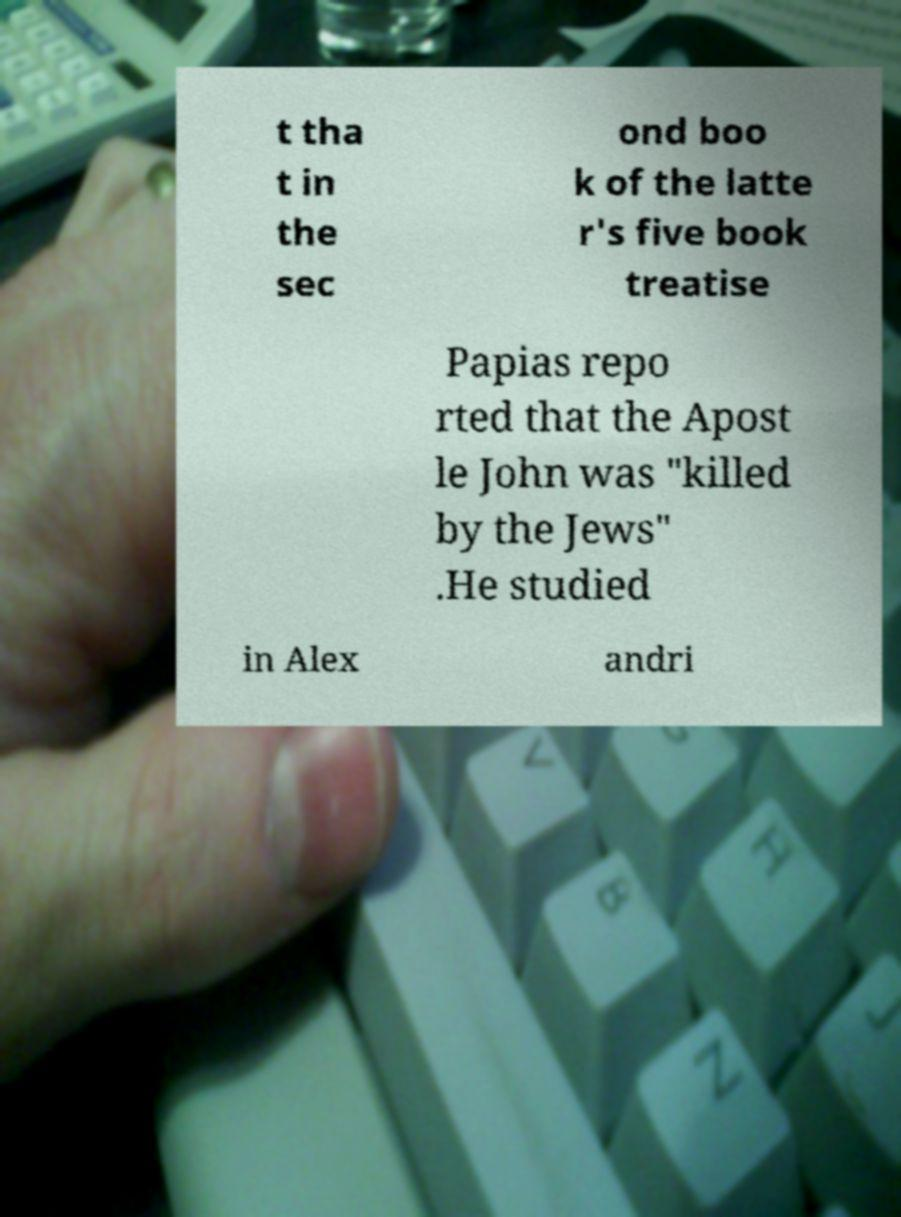Please identify and transcribe the text found in this image. t tha t in the sec ond boo k of the latte r's five book treatise Papias repo rted that the Apost le John was "killed by the Jews" .He studied in Alex andri 